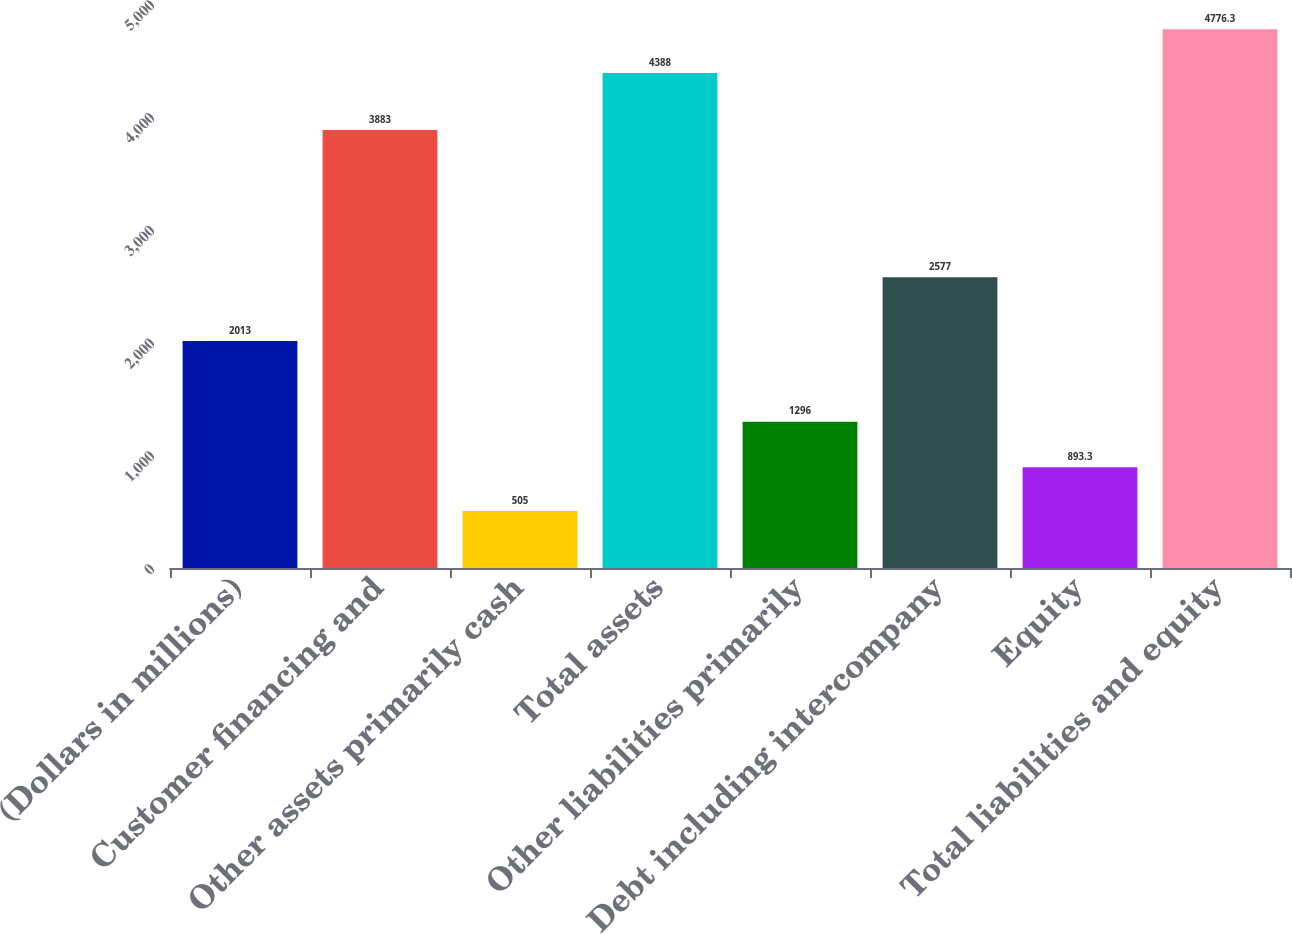Convert chart. <chart><loc_0><loc_0><loc_500><loc_500><bar_chart><fcel>(Dollars in millions)<fcel>Customer financing and<fcel>Other assets primarily cash<fcel>Total assets<fcel>Other liabilities primarily<fcel>Debt including intercompany<fcel>Equity<fcel>Total liabilities and equity<nl><fcel>2013<fcel>3883<fcel>505<fcel>4388<fcel>1296<fcel>2577<fcel>893.3<fcel>4776.3<nl></chart> 